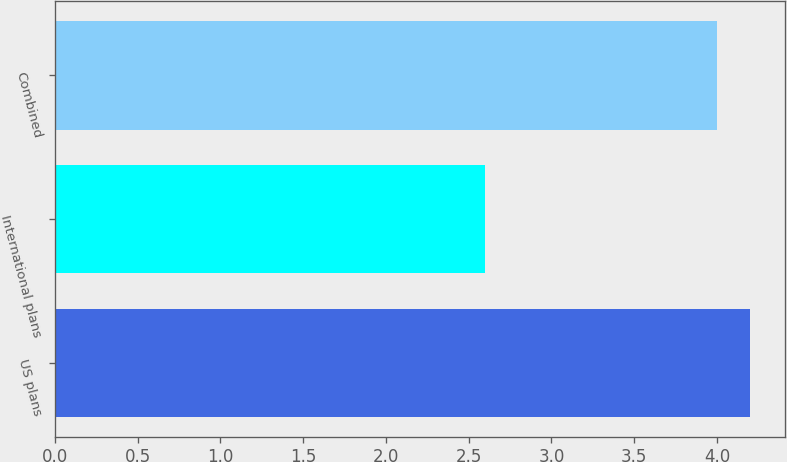Convert chart to OTSL. <chart><loc_0><loc_0><loc_500><loc_500><bar_chart><fcel>US plans<fcel>International plans<fcel>Combined<nl><fcel>4.2<fcel>2.6<fcel>4<nl></chart> 